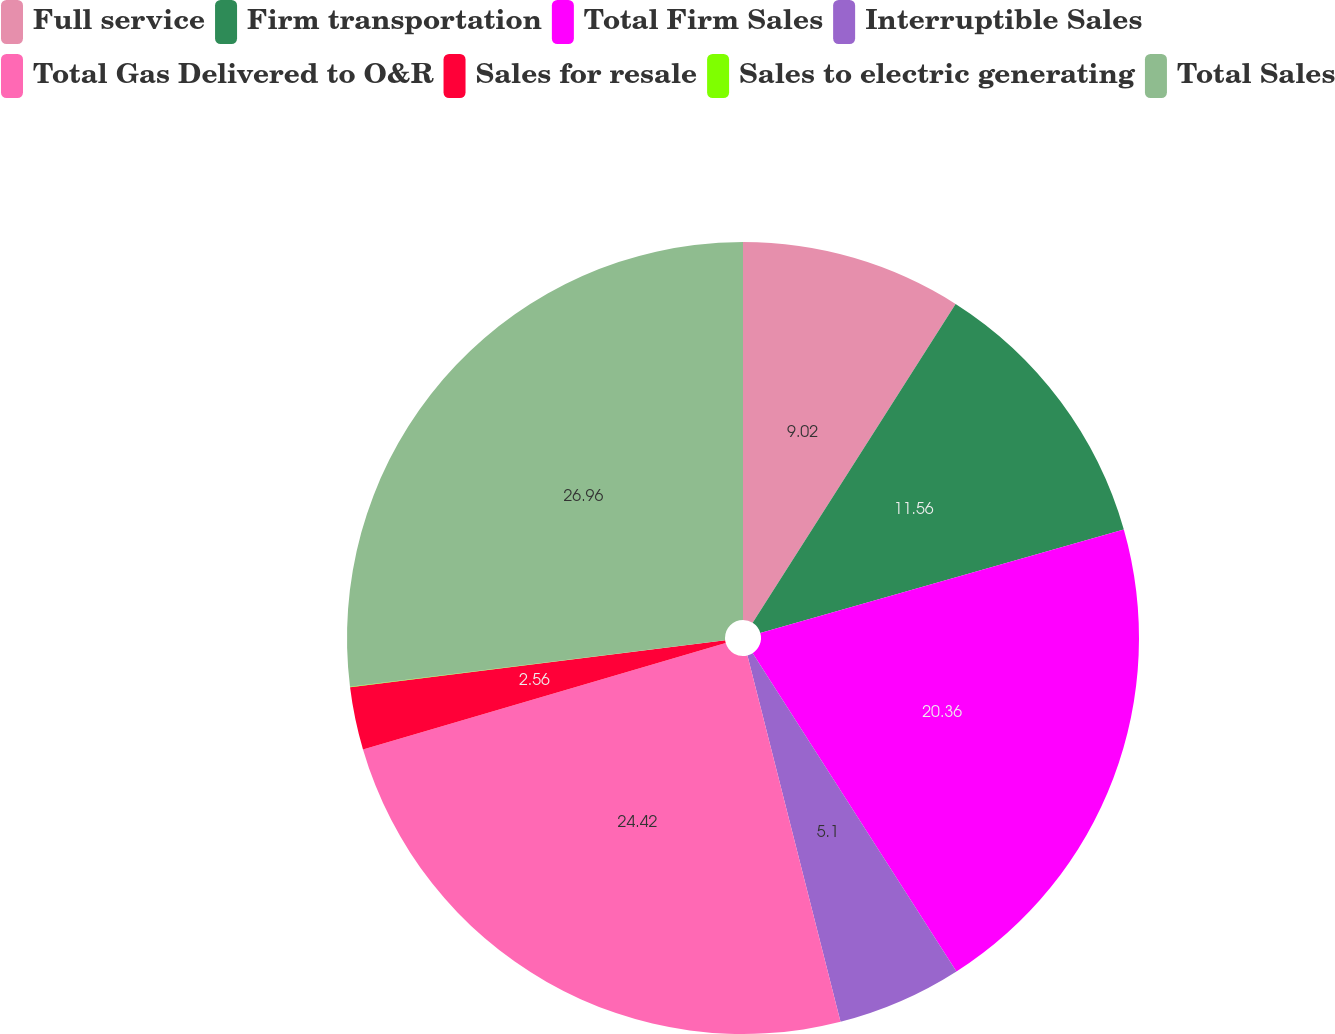Convert chart to OTSL. <chart><loc_0><loc_0><loc_500><loc_500><pie_chart><fcel>Full service<fcel>Firm transportation<fcel>Total Firm Sales<fcel>Interruptible Sales<fcel>Total Gas Delivered to O&R<fcel>Sales for resale<fcel>Sales to electric generating<fcel>Total Sales<nl><fcel>9.02%<fcel>11.56%<fcel>20.36%<fcel>5.1%<fcel>24.42%<fcel>2.56%<fcel>0.02%<fcel>26.96%<nl></chart> 